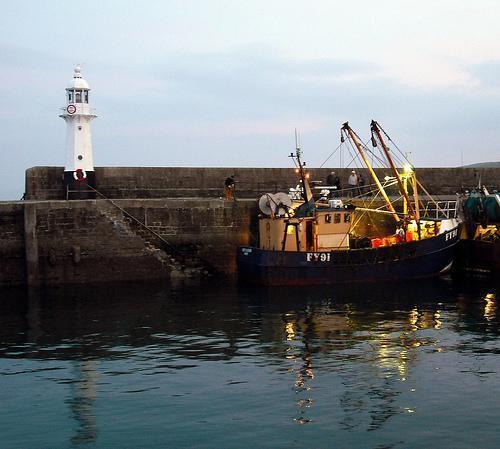How many ships are in the photo?
Give a very brief answer. 1. 